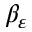Convert formula to latex. <formula><loc_0><loc_0><loc_500><loc_500>\beta _ { \varepsilon }</formula> 